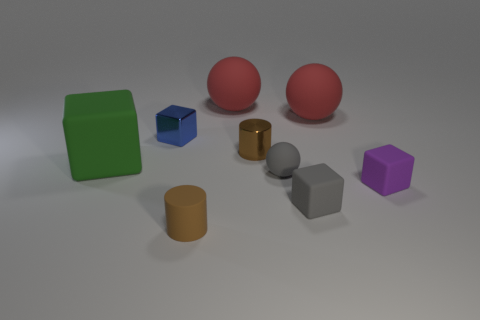What shape is the small rubber thing that is the same color as the small metal cylinder?
Your response must be concise. Cylinder. How many other things are there of the same size as the purple matte object?
Keep it short and to the point. 5. There is a red rubber sphere that is on the right side of the small sphere; is it the same size as the matte cube behind the tiny gray sphere?
Your answer should be compact. Yes. How many things are either large cyan blocks or big rubber things that are on the right side of the small gray sphere?
Give a very brief answer. 1. What size is the thing on the left side of the blue shiny object?
Give a very brief answer. Large. Is the number of blocks that are right of the green rubber object less than the number of rubber objects that are to the right of the brown rubber cylinder?
Ensure brevity in your answer.  Yes. There is a tiny object that is behind the big green block and right of the blue metallic object; what is its material?
Offer a terse response. Metal. The tiny shiny object left of the small brown object that is in front of the green block is what shape?
Offer a terse response. Cube. Is the color of the rubber cylinder the same as the metal cylinder?
Provide a succinct answer. Yes. How many red objects are small shiny spheres or large things?
Your response must be concise. 2. 